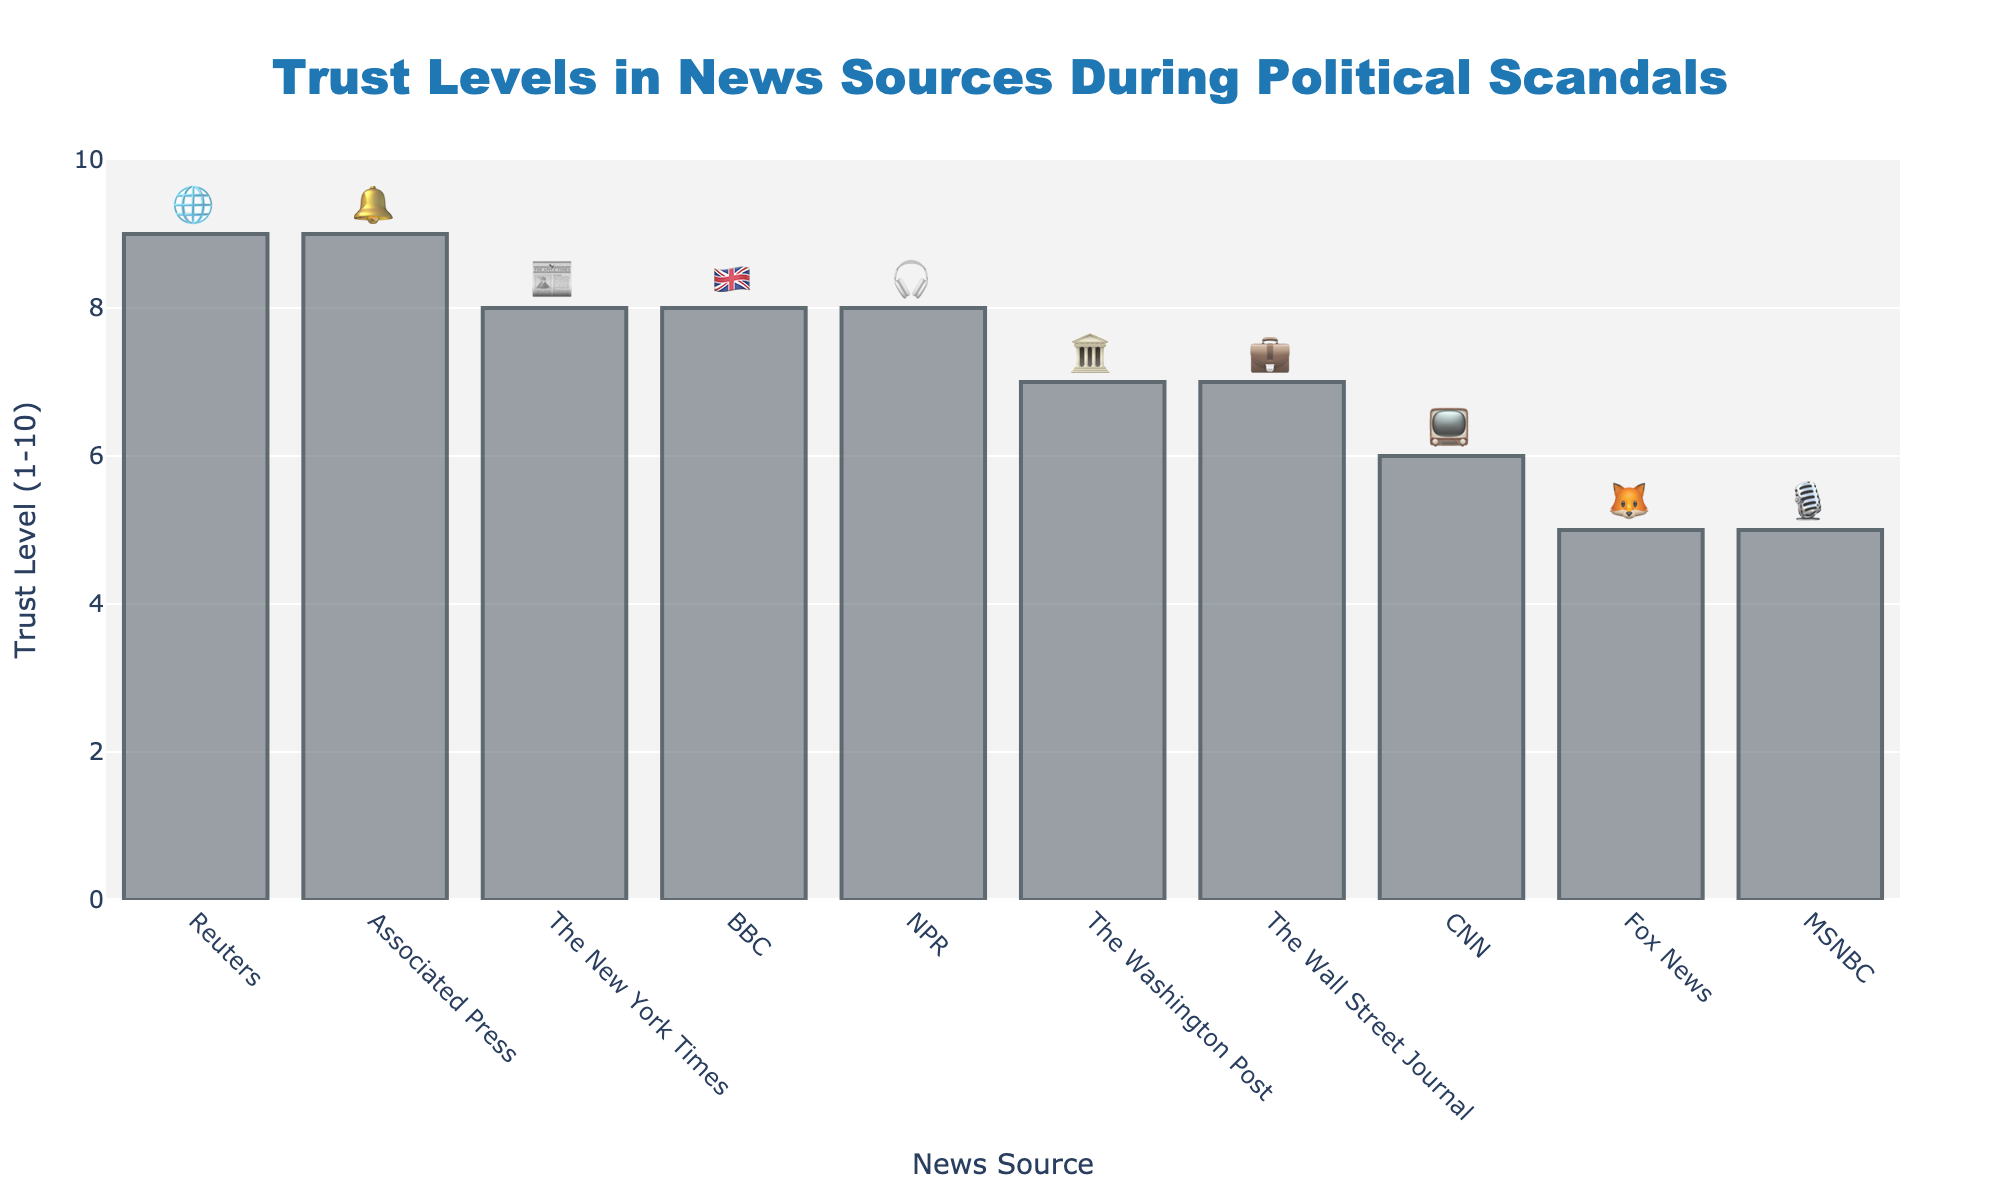What is the title of the chart? The title is displayed at the top center of the figure.
Answer: Trust Levels in News Sources During Political Scandals Which news source has the highest trust level? By inspecting the height of the bars, Associated Press and Reuters have the highest.
Answer: Associated Press and Reuters What is the trust level of CNN? Find the bar labeled as 'CNN' and look at its height in relation to the y-axis.
Answer: 6 Which news source has the lowest trust level? By inspecting the height of the bars, Fox News and MSNBC have the lowest.
Answer: Fox News and MSNBC How many news sources have a trust level of 8 or higher? Look for bars equal to or exceeding 8 and count them. The news sources are The New York Times, BBC, NPR, Reuters, and Associated Press.
Answer: 5 What is the difference in trust level between CNN and Fox News? Subtract Fox News' trust level from CNN's trust level (6 - 5).
Answer: 1 What is the average trust level of all news sources? Add all trust levels and divide by the number of news sources ((6 + 5 + 8 + 9 + 5 + 8 + 7 + 8 + 7 + 9) / 10).
Answer: 7.2 What is the range of the trust levels represented in the chart? Subtract the lowest trust level (5) from the highest trust level (9).
Answer: 4 Which news source with a trust level of 7 is depicted with an emoji relating to business? Look for the bar with trust level 7 and emoji associated with business activities; it's The Wall Street Journal.
Answer: The Wall Street Journal How does The New York Times compare with NPR in terms of trust level? Compare the heights of the bars for The New York Times and NPR; they both have the same trust level of 8.
Answer: They are equal 